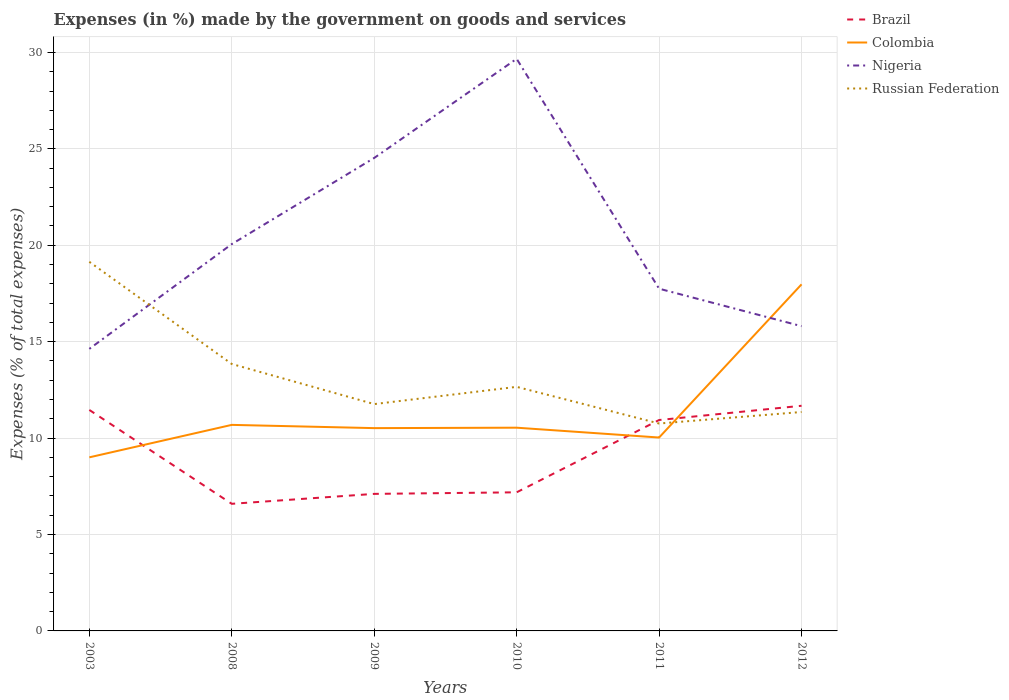How many different coloured lines are there?
Provide a short and direct response. 4. Across all years, what is the maximum percentage of expenses made by the government on goods and services in Brazil?
Ensure brevity in your answer.  6.59. What is the total percentage of expenses made by the government on goods and services in Colombia in the graph?
Your answer should be very brief. -1.51. What is the difference between the highest and the second highest percentage of expenses made by the government on goods and services in Brazil?
Provide a short and direct response. 5.08. Is the percentage of expenses made by the government on goods and services in Colombia strictly greater than the percentage of expenses made by the government on goods and services in Nigeria over the years?
Your answer should be compact. No. How many lines are there?
Offer a terse response. 4. How many years are there in the graph?
Offer a terse response. 6. Does the graph contain any zero values?
Make the answer very short. No. Does the graph contain grids?
Provide a succinct answer. Yes. Where does the legend appear in the graph?
Provide a short and direct response. Top right. How are the legend labels stacked?
Offer a terse response. Vertical. What is the title of the graph?
Your answer should be very brief. Expenses (in %) made by the government on goods and services. Does "Cyprus" appear as one of the legend labels in the graph?
Make the answer very short. No. What is the label or title of the X-axis?
Your answer should be compact. Years. What is the label or title of the Y-axis?
Offer a terse response. Expenses (% of total expenses). What is the Expenses (% of total expenses) in Brazil in 2003?
Ensure brevity in your answer.  11.46. What is the Expenses (% of total expenses) of Colombia in 2003?
Offer a very short reply. 9. What is the Expenses (% of total expenses) of Nigeria in 2003?
Provide a succinct answer. 14.63. What is the Expenses (% of total expenses) in Russian Federation in 2003?
Ensure brevity in your answer.  19.14. What is the Expenses (% of total expenses) of Brazil in 2008?
Offer a terse response. 6.59. What is the Expenses (% of total expenses) of Colombia in 2008?
Your answer should be compact. 10.69. What is the Expenses (% of total expenses) of Nigeria in 2008?
Make the answer very short. 20.06. What is the Expenses (% of total expenses) of Russian Federation in 2008?
Offer a very short reply. 13.84. What is the Expenses (% of total expenses) in Brazil in 2009?
Your response must be concise. 7.11. What is the Expenses (% of total expenses) of Colombia in 2009?
Provide a short and direct response. 10.52. What is the Expenses (% of total expenses) in Nigeria in 2009?
Keep it short and to the point. 24.53. What is the Expenses (% of total expenses) in Russian Federation in 2009?
Offer a very short reply. 11.76. What is the Expenses (% of total expenses) in Brazil in 2010?
Provide a succinct answer. 7.19. What is the Expenses (% of total expenses) of Colombia in 2010?
Keep it short and to the point. 10.54. What is the Expenses (% of total expenses) in Nigeria in 2010?
Your response must be concise. 29.67. What is the Expenses (% of total expenses) in Russian Federation in 2010?
Offer a very short reply. 12.66. What is the Expenses (% of total expenses) in Brazil in 2011?
Your response must be concise. 10.94. What is the Expenses (% of total expenses) in Colombia in 2011?
Provide a short and direct response. 10.03. What is the Expenses (% of total expenses) in Nigeria in 2011?
Ensure brevity in your answer.  17.75. What is the Expenses (% of total expenses) of Russian Federation in 2011?
Your response must be concise. 10.76. What is the Expenses (% of total expenses) of Brazil in 2012?
Offer a very short reply. 11.68. What is the Expenses (% of total expenses) of Colombia in 2012?
Provide a short and direct response. 17.97. What is the Expenses (% of total expenses) of Nigeria in 2012?
Provide a succinct answer. 15.8. What is the Expenses (% of total expenses) in Russian Federation in 2012?
Your response must be concise. 11.35. Across all years, what is the maximum Expenses (% of total expenses) in Brazil?
Offer a very short reply. 11.68. Across all years, what is the maximum Expenses (% of total expenses) of Colombia?
Offer a terse response. 17.97. Across all years, what is the maximum Expenses (% of total expenses) of Nigeria?
Your response must be concise. 29.67. Across all years, what is the maximum Expenses (% of total expenses) of Russian Federation?
Give a very brief answer. 19.14. Across all years, what is the minimum Expenses (% of total expenses) of Brazil?
Offer a terse response. 6.59. Across all years, what is the minimum Expenses (% of total expenses) in Colombia?
Your answer should be compact. 9. Across all years, what is the minimum Expenses (% of total expenses) in Nigeria?
Your response must be concise. 14.63. Across all years, what is the minimum Expenses (% of total expenses) in Russian Federation?
Give a very brief answer. 10.76. What is the total Expenses (% of total expenses) of Brazil in the graph?
Your answer should be very brief. 54.96. What is the total Expenses (% of total expenses) in Colombia in the graph?
Your response must be concise. 68.75. What is the total Expenses (% of total expenses) in Nigeria in the graph?
Offer a very short reply. 122.44. What is the total Expenses (% of total expenses) in Russian Federation in the graph?
Keep it short and to the point. 79.52. What is the difference between the Expenses (% of total expenses) of Brazil in 2003 and that in 2008?
Provide a short and direct response. 4.87. What is the difference between the Expenses (% of total expenses) of Colombia in 2003 and that in 2008?
Make the answer very short. -1.68. What is the difference between the Expenses (% of total expenses) of Nigeria in 2003 and that in 2008?
Offer a terse response. -5.43. What is the difference between the Expenses (% of total expenses) in Russian Federation in 2003 and that in 2008?
Ensure brevity in your answer.  5.3. What is the difference between the Expenses (% of total expenses) of Brazil in 2003 and that in 2009?
Your answer should be very brief. 4.35. What is the difference between the Expenses (% of total expenses) of Colombia in 2003 and that in 2009?
Offer a terse response. -1.51. What is the difference between the Expenses (% of total expenses) of Nigeria in 2003 and that in 2009?
Provide a short and direct response. -9.9. What is the difference between the Expenses (% of total expenses) in Russian Federation in 2003 and that in 2009?
Provide a short and direct response. 7.38. What is the difference between the Expenses (% of total expenses) in Brazil in 2003 and that in 2010?
Your response must be concise. 4.27. What is the difference between the Expenses (% of total expenses) in Colombia in 2003 and that in 2010?
Give a very brief answer. -1.54. What is the difference between the Expenses (% of total expenses) of Nigeria in 2003 and that in 2010?
Give a very brief answer. -15.04. What is the difference between the Expenses (% of total expenses) in Russian Federation in 2003 and that in 2010?
Ensure brevity in your answer.  6.48. What is the difference between the Expenses (% of total expenses) of Brazil in 2003 and that in 2011?
Offer a very short reply. 0.52. What is the difference between the Expenses (% of total expenses) in Colombia in 2003 and that in 2011?
Provide a short and direct response. -1.03. What is the difference between the Expenses (% of total expenses) of Nigeria in 2003 and that in 2011?
Your answer should be compact. -3.12. What is the difference between the Expenses (% of total expenses) in Russian Federation in 2003 and that in 2011?
Your answer should be very brief. 8.39. What is the difference between the Expenses (% of total expenses) in Brazil in 2003 and that in 2012?
Your answer should be compact. -0.22. What is the difference between the Expenses (% of total expenses) in Colombia in 2003 and that in 2012?
Give a very brief answer. -8.97. What is the difference between the Expenses (% of total expenses) of Nigeria in 2003 and that in 2012?
Make the answer very short. -1.18. What is the difference between the Expenses (% of total expenses) in Russian Federation in 2003 and that in 2012?
Make the answer very short. 7.79. What is the difference between the Expenses (% of total expenses) in Brazil in 2008 and that in 2009?
Your answer should be compact. -0.52. What is the difference between the Expenses (% of total expenses) of Colombia in 2008 and that in 2009?
Keep it short and to the point. 0.17. What is the difference between the Expenses (% of total expenses) of Nigeria in 2008 and that in 2009?
Your response must be concise. -4.47. What is the difference between the Expenses (% of total expenses) in Russian Federation in 2008 and that in 2009?
Offer a very short reply. 2.08. What is the difference between the Expenses (% of total expenses) in Brazil in 2008 and that in 2010?
Offer a very short reply. -0.6. What is the difference between the Expenses (% of total expenses) in Colombia in 2008 and that in 2010?
Offer a very short reply. 0.15. What is the difference between the Expenses (% of total expenses) in Nigeria in 2008 and that in 2010?
Keep it short and to the point. -9.61. What is the difference between the Expenses (% of total expenses) of Russian Federation in 2008 and that in 2010?
Your answer should be very brief. 1.19. What is the difference between the Expenses (% of total expenses) of Brazil in 2008 and that in 2011?
Make the answer very short. -4.35. What is the difference between the Expenses (% of total expenses) in Colombia in 2008 and that in 2011?
Offer a very short reply. 0.66. What is the difference between the Expenses (% of total expenses) of Nigeria in 2008 and that in 2011?
Provide a succinct answer. 2.31. What is the difference between the Expenses (% of total expenses) in Russian Federation in 2008 and that in 2011?
Ensure brevity in your answer.  3.09. What is the difference between the Expenses (% of total expenses) in Brazil in 2008 and that in 2012?
Ensure brevity in your answer.  -5.08. What is the difference between the Expenses (% of total expenses) in Colombia in 2008 and that in 2012?
Your response must be concise. -7.29. What is the difference between the Expenses (% of total expenses) in Nigeria in 2008 and that in 2012?
Offer a very short reply. 4.26. What is the difference between the Expenses (% of total expenses) of Russian Federation in 2008 and that in 2012?
Offer a terse response. 2.49. What is the difference between the Expenses (% of total expenses) in Brazil in 2009 and that in 2010?
Your answer should be very brief. -0.08. What is the difference between the Expenses (% of total expenses) of Colombia in 2009 and that in 2010?
Ensure brevity in your answer.  -0.02. What is the difference between the Expenses (% of total expenses) in Nigeria in 2009 and that in 2010?
Your response must be concise. -5.14. What is the difference between the Expenses (% of total expenses) in Russian Federation in 2009 and that in 2010?
Offer a terse response. -0.89. What is the difference between the Expenses (% of total expenses) in Brazil in 2009 and that in 2011?
Your response must be concise. -3.83. What is the difference between the Expenses (% of total expenses) of Colombia in 2009 and that in 2011?
Offer a very short reply. 0.49. What is the difference between the Expenses (% of total expenses) of Nigeria in 2009 and that in 2011?
Ensure brevity in your answer.  6.78. What is the difference between the Expenses (% of total expenses) in Russian Federation in 2009 and that in 2011?
Make the answer very short. 1.01. What is the difference between the Expenses (% of total expenses) in Brazil in 2009 and that in 2012?
Provide a short and direct response. -4.57. What is the difference between the Expenses (% of total expenses) in Colombia in 2009 and that in 2012?
Your answer should be very brief. -7.46. What is the difference between the Expenses (% of total expenses) in Nigeria in 2009 and that in 2012?
Give a very brief answer. 8.72. What is the difference between the Expenses (% of total expenses) of Russian Federation in 2009 and that in 2012?
Offer a terse response. 0.41. What is the difference between the Expenses (% of total expenses) of Brazil in 2010 and that in 2011?
Your answer should be very brief. -3.75. What is the difference between the Expenses (% of total expenses) of Colombia in 2010 and that in 2011?
Your answer should be very brief. 0.51. What is the difference between the Expenses (% of total expenses) in Nigeria in 2010 and that in 2011?
Make the answer very short. 11.92. What is the difference between the Expenses (% of total expenses) of Russian Federation in 2010 and that in 2011?
Ensure brevity in your answer.  1.9. What is the difference between the Expenses (% of total expenses) in Brazil in 2010 and that in 2012?
Your response must be concise. -4.49. What is the difference between the Expenses (% of total expenses) in Colombia in 2010 and that in 2012?
Ensure brevity in your answer.  -7.43. What is the difference between the Expenses (% of total expenses) in Nigeria in 2010 and that in 2012?
Your answer should be compact. 13.86. What is the difference between the Expenses (% of total expenses) in Russian Federation in 2010 and that in 2012?
Make the answer very short. 1.3. What is the difference between the Expenses (% of total expenses) in Brazil in 2011 and that in 2012?
Provide a succinct answer. -0.74. What is the difference between the Expenses (% of total expenses) of Colombia in 2011 and that in 2012?
Provide a succinct answer. -7.94. What is the difference between the Expenses (% of total expenses) of Nigeria in 2011 and that in 2012?
Your answer should be compact. 1.94. What is the difference between the Expenses (% of total expenses) of Russian Federation in 2011 and that in 2012?
Your response must be concise. -0.6. What is the difference between the Expenses (% of total expenses) of Brazil in 2003 and the Expenses (% of total expenses) of Colombia in 2008?
Your answer should be compact. 0.77. What is the difference between the Expenses (% of total expenses) of Brazil in 2003 and the Expenses (% of total expenses) of Nigeria in 2008?
Offer a very short reply. -8.6. What is the difference between the Expenses (% of total expenses) in Brazil in 2003 and the Expenses (% of total expenses) in Russian Federation in 2008?
Offer a terse response. -2.38. What is the difference between the Expenses (% of total expenses) in Colombia in 2003 and the Expenses (% of total expenses) in Nigeria in 2008?
Provide a succinct answer. -11.06. What is the difference between the Expenses (% of total expenses) of Colombia in 2003 and the Expenses (% of total expenses) of Russian Federation in 2008?
Keep it short and to the point. -4.84. What is the difference between the Expenses (% of total expenses) of Nigeria in 2003 and the Expenses (% of total expenses) of Russian Federation in 2008?
Offer a terse response. 0.78. What is the difference between the Expenses (% of total expenses) of Brazil in 2003 and the Expenses (% of total expenses) of Colombia in 2009?
Offer a very short reply. 0.94. What is the difference between the Expenses (% of total expenses) of Brazil in 2003 and the Expenses (% of total expenses) of Nigeria in 2009?
Your response must be concise. -13.07. What is the difference between the Expenses (% of total expenses) of Brazil in 2003 and the Expenses (% of total expenses) of Russian Federation in 2009?
Your answer should be very brief. -0.3. What is the difference between the Expenses (% of total expenses) in Colombia in 2003 and the Expenses (% of total expenses) in Nigeria in 2009?
Offer a very short reply. -15.53. What is the difference between the Expenses (% of total expenses) of Colombia in 2003 and the Expenses (% of total expenses) of Russian Federation in 2009?
Give a very brief answer. -2.76. What is the difference between the Expenses (% of total expenses) in Nigeria in 2003 and the Expenses (% of total expenses) in Russian Federation in 2009?
Make the answer very short. 2.86. What is the difference between the Expenses (% of total expenses) of Brazil in 2003 and the Expenses (% of total expenses) of Colombia in 2010?
Provide a succinct answer. 0.92. What is the difference between the Expenses (% of total expenses) of Brazil in 2003 and the Expenses (% of total expenses) of Nigeria in 2010?
Make the answer very short. -18.21. What is the difference between the Expenses (% of total expenses) of Brazil in 2003 and the Expenses (% of total expenses) of Russian Federation in 2010?
Keep it short and to the point. -1.2. What is the difference between the Expenses (% of total expenses) of Colombia in 2003 and the Expenses (% of total expenses) of Nigeria in 2010?
Provide a succinct answer. -20.67. What is the difference between the Expenses (% of total expenses) of Colombia in 2003 and the Expenses (% of total expenses) of Russian Federation in 2010?
Keep it short and to the point. -3.66. What is the difference between the Expenses (% of total expenses) in Nigeria in 2003 and the Expenses (% of total expenses) in Russian Federation in 2010?
Provide a succinct answer. 1.97. What is the difference between the Expenses (% of total expenses) in Brazil in 2003 and the Expenses (% of total expenses) in Colombia in 2011?
Your answer should be compact. 1.43. What is the difference between the Expenses (% of total expenses) of Brazil in 2003 and the Expenses (% of total expenses) of Nigeria in 2011?
Offer a terse response. -6.29. What is the difference between the Expenses (% of total expenses) in Brazil in 2003 and the Expenses (% of total expenses) in Russian Federation in 2011?
Offer a terse response. 0.7. What is the difference between the Expenses (% of total expenses) of Colombia in 2003 and the Expenses (% of total expenses) of Nigeria in 2011?
Ensure brevity in your answer.  -8.75. What is the difference between the Expenses (% of total expenses) of Colombia in 2003 and the Expenses (% of total expenses) of Russian Federation in 2011?
Make the answer very short. -1.75. What is the difference between the Expenses (% of total expenses) in Nigeria in 2003 and the Expenses (% of total expenses) in Russian Federation in 2011?
Provide a succinct answer. 3.87. What is the difference between the Expenses (% of total expenses) in Brazil in 2003 and the Expenses (% of total expenses) in Colombia in 2012?
Offer a terse response. -6.51. What is the difference between the Expenses (% of total expenses) of Brazil in 2003 and the Expenses (% of total expenses) of Nigeria in 2012?
Offer a terse response. -4.34. What is the difference between the Expenses (% of total expenses) in Brazil in 2003 and the Expenses (% of total expenses) in Russian Federation in 2012?
Give a very brief answer. 0.11. What is the difference between the Expenses (% of total expenses) of Colombia in 2003 and the Expenses (% of total expenses) of Nigeria in 2012?
Your response must be concise. -6.8. What is the difference between the Expenses (% of total expenses) in Colombia in 2003 and the Expenses (% of total expenses) in Russian Federation in 2012?
Provide a succinct answer. -2.35. What is the difference between the Expenses (% of total expenses) in Nigeria in 2003 and the Expenses (% of total expenses) in Russian Federation in 2012?
Give a very brief answer. 3.27. What is the difference between the Expenses (% of total expenses) in Brazil in 2008 and the Expenses (% of total expenses) in Colombia in 2009?
Offer a terse response. -3.92. What is the difference between the Expenses (% of total expenses) of Brazil in 2008 and the Expenses (% of total expenses) of Nigeria in 2009?
Provide a succinct answer. -17.94. What is the difference between the Expenses (% of total expenses) of Brazil in 2008 and the Expenses (% of total expenses) of Russian Federation in 2009?
Offer a terse response. -5.17. What is the difference between the Expenses (% of total expenses) of Colombia in 2008 and the Expenses (% of total expenses) of Nigeria in 2009?
Ensure brevity in your answer.  -13.84. What is the difference between the Expenses (% of total expenses) of Colombia in 2008 and the Expenses (% of total expenses) of Russian Federation in 2009?
Offer a terse response. -1.08. What is the difference between the Expenses (% of total expenses) in Nigeria in 2008 and the Expenses (% of total expenses) in Russian Federation in 2009?
Ensure brevity in your answer.  8.3. What is the difference between the Expenses (% of total expenses) in Brazil in 2008 and the Expenses (% of total expenses) in Colombia in 2010?
Keep it short and to the point. -3.95. What is the difference between the Expenses (% of total expenses) in Brazil in 2008 and the Expenses (% of total expenses) in Nigeria in 2010?
Offer a terse response. -23.08. What is the difference between the Expenses (% of total expenses) in Brazil in 2008 and the Expenses (% of total expenses) in Russian Federation in 2010?
Give a very brief answer. -6.07. What is the difference between the Expenses (% of total expenses) in Colombia in 2008 and the Expenses (% of total expenses) in Nigeria in 2010?
Your answer should be very brief. -18.98. What is the difference between the Expenses (% of total expenses) in Colombia in 2008 and the Expenses (% of total expenses) in Russian Federation in 2010?
Ensure brevity in your answer.  -1.97. What is the difference between the Expenses (% of total expenses) in Nigeria in 2008 and the Expenses (% of total expenses) in Russian Federation in 2010?
Provide a short and direct response. 7.4. What is the difference between the Expenses (% of total expenses) of Brazil in 2008 and the Expenses (% of total expenses) of Colombia in 2011?
Keep it short and to the point. -3.44. What is the difference between the Expenses (% of total expenses) in Brazil in 2008 and the Expenses (% of total expenses) in Nigeria in 2011?
Offer a terse response. -11.16. What is the difference between the Expenses (% of total expenses) of Brazil in 2008 and the Expenses (% of total expenses) of Russian Federation in 2011?
Your answer should be compact. -4.16. What is the difference between the Expenses (% of total expenses) in Colombia in 2008 and the Expenses (% of total expenses) in Nigeria in 2011?
Offer a terse response. -7.06. What is the difference between the Expenses (% of total expenses) in Colombia in 2008 and the Expenses (% of total expenses) in Russian Federation in 2011?
Offer a very short reply. -0.07. What is the difference between the Expenses (% of total expenses) in Nigeria in 2008 and the Expenses (% of total expenses) in Russian Federation in 2011?
Your answer should be very brief. 9.3. What is the difference between the Expenses (% of total expenses) in Brazil in 2008 and the Expenses (% of total expenses) in Colombia in 2012?
Make the answer very short. -11.38. What is the difference between the Expenses (% of total expenses) in Brazil in 2008 and the Expenses (% of total expenses) in Nigeria in 2012?
Your answer should be compact. -9.21. What is the difference between the Expenses (% of total expenses) in Brazil in 2008 and the Expenses (% of total expenses) in Russian Federation in 2012?
Keep it short and to the point. -4.76. What is the difference between the Expenses (% of total expenses) in Colombia in 2008 and the Expenses (% of total expenses) in Nigeria in 2012?
Ensure brevity in your answer.  -5.12. What is the difference between the Expenses (% of total expenses) in Colombia in 2008 and the Expenses (% of total expenses) in Russian Federation in 2012?
Offer a terse response. -0.67. What is the difference between the Expenses (% of total expenses) of Nigeria in 2008 and the Expenses (% of total expenses) of Russian Federation in 2012?
Provide a succinct answer. 8.71. What is the difference between the Expenses (% of total expenses) of Brazil in 2009 and the Expenses (% of total expenses) of Colombia in 2010?
Keep it short and to the point. -3.43. What is the difference between the Expenses (% of total expenses) in Brazil in 2009 and the Expenses (% of total expenses) in Nigeria in 2010?
Ensure brevity in your answer.  -22.56. What is the difference between the Expenses (% of total expenses) of Brazil in 2009 and the Expenses (% of total expenses) of Russian Federation in 2010?
Your response must be concise. -5.55. What is the difference between the Expenses (% of total expenses) of Colombia in 2009 and the Expenses (% of total expenses) of Nigeria in 2010?
Ensure brevity in your answer.  -19.15. What is the difference between the Expenses (% of total expenses) in Colombia in 2009 and the Expenses (% of total expenses) in Russian Federation in 2010?
Keep it short and to the point. -2.14. What is the difference between the Expenses (% of total expenses) of Nigeria in 2009 and the Expenses (% of total expenses) of Russian Federation in 2010?
Your answer should be very brief. 11.87. What is the difference between the Expenses (% of total expenses) of Brazil in 2009 and the Expenses (% of total expenses) of Colombia in 2011?
Make the answer very short. -2.92. What is the difference between the Expenses (% of total expenses) of Brazil in 2009 and the Expenses (% of total expenses) of Nigeria in 2011?
Offer a very short reply. -10.64. What is the difference between the Expenses (% of total expenses) in Brazil in 2009 and the Expenses (% of total expenses) in Russian Federation in 2011?
Your answer should be compact. -3.65. What is the difference between the Expenses (% of total expenses) of Colombia in 2009 and the Expenses (% of total expenses) of Nigeria in 2011?
Make the answer very short. -7.23. What is the difference between the Expenses (% of total expenses) of Colombia in 2009 and the Expenses (% of total expenses) of Russian Federation in 2011?
Your answer should be compact. -0.24. What is the difference between the Expenses (% of total expenses) in Nigeria in 2009 and the Expenses (% of total expenses) in Russian Federation in 2011?
Ensure brevity in your answer.  13.77. What is the difference between the Expenses (% of total expenses) of Brazil in 2009 and the Expenses (% of total expenses) of Colombia in 2012?
Ensure brevity in your answer.  -10.87. What is the difference between the Expenses (% of total expenses) in Brazil in 2009 and the Expenses (% of total expenses) in Nigeria in 2012?
Your answer should be very brief. -8.7. What is the difference between the Expenses (% of total expenses) of Brazil in 2009 and the Expenses (% of total expenses) of Russian Federation in 2012?
Offer a very short reply. -4.25. What is the difference between the Expenses (% of total expenses) in Colombia in 2009 and the Expenses (% of total expenses) in Nigeria in 2012?
Your response must be concise. -5.29. What is the difference between the Expenses (% of total expenses) in Colombia in 2009 and the Expenses (% of total expenses) in Russian Federation in 2012?
Your answer should be very brief. -0.84. What is the difference between the Expenses (% of total expenses) in Nigeria in 2009 and the Expenses (% of total expenses) in Russian Federation in 2012?
Your answer should be compact. 13.18. What is the difference between the Expenses (% of total expenses) of Brazil in 2010 and the Expenses (% of total expenses) of Colombia in 2011?
Give a very brief answer. -2.84. What is the difference between the Expenses (% of total expenses) in Brazil in 2010 and the Expenses (% of total expenses) in Nigeria in 2011?
Offer a terse response. -10.56. What is the difference between the Expenses (% of total expenses) in Brazil in 2010 and the Expenses (% of total expenses) in Russian Federation in 2011?
Provide a short and direct response. -3.57. What is the difference between the Expenses (% of total expenses) of Colombia in 2010 and the Expenses (% of total expenses) of Nigeria in 2011?
Offer a very short reply. -7.21. What is the difference between the Expenses (% of total expenses) of Colombia in 2010 and the Expenses (% of total expenses) of Russian Federation in 2011?
Make the answer very short. -0.22. What is the difference between the Expenses (% of total expenses) of Nigeria in 2010 and the Expenses (% of total expenses) of Russian Federation in 2011?
Your response must be concise. 18.91. What is the difference between the Expenses (% of total expenses) of Brazil in 2010 and the Expenses (% of total expenses) of Colombia in 2012?
Your answer should be very brief. -10.79. What is the difference between the Expenses (% of total expenses) in Brazil in 2010 and the Expenses (% of total expenses) in Nigeria in 2012?
Your answer should be compact. -8.62. What is the difference between the Expenses (% of total expenses) of Brazil in 2010 and the Expenses (% of total expenses) of Russian Federation in 2012?
Your response must be concise. -4.17. What is the difference between the Expenses (% of total expenses) of Colombia in 2010 and the Expenses (% of total expenses) of Nigeria in 2012?
Your answer should be very brief. -5.27. What is the difference between the Expenses (% of total expenses) of Colombia in 2010 and the Expenses (% of total expenses) of Russian Federation in 2012?
Your response must be concise. -0.81. What is the difference between the Expenses (% of total expenses) in Nigeria in 2010 and the Expenses (% of total expenses) in Russian Federation in 2012?
Offer a terse response. 18.32. What is the difference between the Expenses (% of total expenses) in Brazil in 2011 and the Expenses (% of total expenses) in Colombia in 2012?
Offer a terse response. -7.04. What is the difference between the Expenses (% of total expenses) in Brazil in 2011 and the Expenses (% of total expenses) in Nigeria in 2012?
Offer a terse response. -4.87. What is the difference between the Expenses (% of total expenses) in Brazil in 2011 and the Expenses (% of total expenses) in Russian Federation in 2012?
Your answer should be compact. -0.42. What is the difference between the Expenses (% of total expenses) in Colombia in 2011 and the Expenses (% of total expenses) in Nigeria in 2012?
Provide a short and direct response. -5.78. What is the difference between the Expenses (% of total expenses) in Colombia in 2011 and the Expenses (% of total expenses) in Russian Federation in 2012?
Your response must be concise. -1.32. What is the difference between the Expenses (% of total expenses) of Nigeria in 2011 and the Expenses (% of total expenses) of Russian Federation in 2012?
Offer a very short reply. 6.39. What is the average Expenses (% of total expenses) in Brazil per year?
Keep it short and to the point. 9.16. What is the average Expenses (% of total expenses) of Colombia per year?
Make the answer very short. 11.46. What is the average Expenses (% of total expenses) of Nigeria per year?
Your answer should be very brief. 20.41. What is the average Expenses (% of total expenses) of Russian Federation per year?
Your answer should be very brief. 13.25. In the year 2003, what is the difference between the Expenses (% of total expenses) in Brazil and Expenses (% of total expenses) in Colombia?
Ensure brevity in your answer.  2.46. In the year 2003, what is the difference between the Expenses (% of total expenses) in Brazil and Expenses (% of total expenses) in Nigeria?
Your answer should be very brief. -3.17. In the year 2003, what is the difference between the Expenses (% of total expenses) in Brazil and Expenses (% of total expenses) in Russian Federation?
Provide a succinct answer. -7.68. In the year 2003, what is the difference between the Expenses (% of total expenses) in Colombia and Expenses (% of total expenses) in Nigeria?
Offer a very short reply. -5.62. In the year 2003, what is the difference between the Expenses (% of total expenses) in Colombia and Expenses (% of total expenses) in Russian Federation?
Provide a short and direct response. -10.14. In the year 2003, what is the difference between the Expenses (% of total expenses) of Nigeria and Expenses (% of total expenses) of Russian Federation?
Your answer should be very brief. -4.52. In the year 2008, what is the difference between the Expenses (% of total expenses) of Brazil and Expenses (% of total expenses) of Colombia?
Make the answer very short. -4.09. In the year 2008, what is the difference between the Expenses (% of total expenses) in Brazil and Expenses (% of total expenses) in Nigeria?
Provide a short and direct response. -13.47. In the year 2008, what is the difference between the Expenses (% of total expenses) in Brazil and Expenses (% of total expenses) in Russian Federation?
Ensure brevity in your answer.  -7.25. In the year 2008, what is the difference between the Expenses (% of total expenses) in Colombia and Expenses (% of total expenses) in Nigeria?
Your answer should be compact. -9.38. In the year 2008, what is the difference between the Expenses (% of total expenses) of Colombia and Expenses (% of total expenses) of Russian Federation?
Provide a succinct answer. -3.16. In the year 2008, what is the difference between the Expenses (% of total expenses) in Nigeria and Expenses (% of total expenses) in Russian Federation?
Offer a very short reply. 6.22. In the year 2009, what is the difference between the Expenses (% of total expenses) of Brazil and Expenses (% of total expenses) of Colombia?
Ensure brevity in your answer.  -3.41. In the year 2009, what is the difference between the Expenses (% of total expenses) of Brazil and Expenses (% of total expenses) of Nigeria?
Provide a succinct answer. -17.42. In the year 2009, what is the difference between the Expenses (% of total expenses) in Brazil and Expenses (% of total expenses) in Russian Federation?
Your answer should be very brief. -4.66. In the year 2009, what is the difference between the Expenses (% of total expenses) of Colombia and Expenses (% of total expenses) of Nigeria?
Make the answer very short. -14.01. In the year 2009, what is the difference between the Expenses (% of total expenses) of Colombia and Expenses (% of total expenses) of Russian Federation?
Ensure brevity in your answer.  -1.25. In the year 2009, what is the difference between the Expenses (% of total expenses) in Nigeria and Expenses (% of total expenses) in Russian Federation?
Offer a very short reply. 12.77. In the year 2010, what is the difference between the Expenses (% of total expenses) of Brazil and Expenses (% of total expenses) of Colombia?
Ensure brevity in your answer.  -3.35. In the year 2010, what is the difference between the Expenses (% of total expenses) in Brazil and Expenses (% of total expenses) in Nigeria?
Your answer should be compact. -22.48. In the year 2010, what is the difference between the Expenses (% of total expenses) of Brazil and Expenses (% of total expenses) of Russian Federation?
Your answer should be very brief. -5.47. In the year 2010, what is the difference between the Expenses (% of total expenses) in Colombia and Expenses (% of total expenses) in Nigeria?
Give a very brief answer. -19.13. In the year 2010, what is the difference between the Expenses (% of total expenses) in Colombia and Expenses (% of total expenses) in Russian Federation?
Provide a succinct answer. -2.12. In the year 2010, what is the difference between the Expenses (% of total expenses) of Nigeria and Expenses (% of total expenses) of Russian Federation?
Make the answer very short. 17.01. In the year 2011, what is the difference between the Expenses (% of total expenses) of Brazil and Expenses (% of total expenses) of Colombia?
Your answer should be compact. 0.91. In the year 2011, what is the difference between the Expenses (% of total expenses) in Brazil and Expenses (% of total expenses) in Nigeria?
Your response must be concise. -6.81. In the year 2011, what is the difference between the Expenses (% of total expenses) in Brazil and Expenses (% of total expenses) in Russian Federation?
Your answer should be very brief. 0.18. In the year 2011, what is the difference between the Expenses (% of total expenses) in Colombia and Expenses (% of total expenses) in Nigeria?
Offer a very short reply. -7.72. In the year 2011, what is the difference between the Expenses (% of total expenses) of Colombia and Expenses (% of total expenses) of Russian Federation?
Offer a very short reply. -0.73. In the year 2011, what is the difference between the Expenses (% of total expenses) in Nigeria and Expenses (% of total expenses) in Russian Federation?
Provide a short and direct response. 6.99. In the year 2012, what is the difference between the Expenses (% of total expenses) of Brazil and Expenses (% of total expenses) of Colombia?
Keep it short and to the point. -6.3. In the year 2012, what is the difference between the Expenses (% of total expenses) of Brazil and Expenses (% of total expenses) of Nigeria?
Your answer should be compact. -4.13. In the year 2012, what is the difference between the Expenses (% of total expenses) of Brazil and Expenses (% of total expenses) of Russian Federation?
Provide a short and direct response. 0.32. In the year 2012, what is the difference between the Expenses (% of total expenses) of Colombia and Expenses (% of total expenses) of Nigeria?
Provide a short and direct response. 2.17. In the year 2012, what is the difference between the Expenses (% of total expenses) of Colombia and Expenses (% of total expenses) of Russian Federation?
Offer a terse response. 6.62. In the year 2012, what is the difference between the Expenses (% of total expenses) in Nigeria and Expenses (% of total expenses) in Russian Federation?
Ensure brevity in your answer.  4.45. What is the ratio of the Expenses (% of total expenses) in Brazil in 2003 to that in 2008?
Your answer should be very brief. 1.74. What is the ratio of the Expenses (% of total expenses) of Colombia in 2003 to that in 2008?
Offer a terse response. 0.84. What is the ratio of the Expenses (% of total expenses) of Nigeria in 2003 to that in 2008?
Offer a very short reply. 0.73. What is the ratio of the Expenses (% of total expenses) of Russian Federation in 2003 to that in 2008?
Offer a very short reply. 1.38. What is the ratio of the Expenses (% of total expenses) in Brazil in 2003 to that in 2009?
Give a very brief answer. 1.61. What is the ratio of the Expenses (% of total expenses) of Colombia in 2003 to that in 2009?
Your response must be concise. 0.86. What is the ratio of the Expenses (% of total expenses) in Nigeria in 2003 to that in 2009?
Your response must be concise. 0.6. What is the ratio of the Expenses (% of total expenses) of Russian Federation in 2003 to that in 2009?
Your response must be concise. 1.63. What is the ratio of the Expenses (% of total expenses) in Brazil in 2003 to that in 2010?
Your response must be concise. 1.59. What is the ratio of the Expenses (% of total expenses) of Colombia in 2003 to that in 2010?
Your response must be concise. 0.85. What is the ratio of the Expenses (% of total expenses) of Nigeria in 2003 to that in 2010?
Provide a short and direct response. 0.49. What is the ratio of the Expenses (% of total expenses) of Russian Federation in 2003 to that in 2010?
Your response must be concise. 1.51. What is the ratio of the Expenses (% of total expenses) of Brazil in 2003 to that in 2011?
Offer a very short reply. 1.05. What is the ratio of the Expenses (% of total expenses) in Colombia in 2003 to that in 2011?
Offer a very short reply. 0.9. What is the ratio of the Expenses (% of total expenses) in Nigeria in 2003 to that in 2011?
Your answer should be compact. 0.82. What is the ratio of the Expenses (% of total expenses) in Russian Federation in 2003 to that in 2011?
Keep it short and to the point. 1.78. What is the ratio of the Expenses (% of total expenses) in Brazil in 2003 to that in 2012?
Your response must be concise. 0.98. What is the ratio of the Expenses (% of total expenses) in Colombia in 2003 to that in 2012?
Keep it short and to the point. 0.5. What is the ratio of the Expenses (% of total expenses) of Nigeria in 2003 to that in 2012?
Your response must be concise. 0.93. What is the ratio of the Expenses (% of total expenses) of Russian Federation in 2003 to that in 2012?
Your answer should be very brief. 1.69. What is the ratio of the Expenses (% of total expenses) in Brazil in 2008 to that in 2009?
Offer a very short reply. 0.93. What is the ratio of the Expenses (% of total expenses) of Colombia in 2008 to that in 2009?
Make the answer very short. 1.02. What is the ratio of the Expenses (% of total expenses) of Nigeria in 2008 to that in 2009?
Your answer should be compact. 0.82. What is the ratio of the Expenses (% of total expenses) in Russian Federation in 2008 to that in 2009?
Make the answer very short. 1.18. What is the ratio of the Expenses (% of total expenses) in Brazil in 2008 to that in 2010?
Your answer should be compact. 0.92. What is the ratio of the Expenses (% of total expenses) in Colombia in 2008 to that in 2010?
Offer a terse response. 1.01. What is the ratio of the Expenses (% of total expenses) in Nigeria in 2008 to that in 2010?
Your answer should be compact. 0.68. What is the ratio of the Expenses (% of total expenses) in Russian Federation in 2008 to that in 2010?
Give a very brief answer. 1.09. What is the ratio of the Expenses (% of total expenses) in Brazil in 2008 to that in 2011?
Make the answer very short. 0.6. What is the ratio of the Expenses (% of total expenses) of Colombia in 2008 to that in 2011?
Provide a short and direct response. 1.07. What is the ratio of the Expenses (% of total expenses) of Nigeria in 2008 to that in 2011?
Provide a succinct answer. 1.13. What is the ratio of the Expenses (% of total expenses) in Russian Federation in 2008 to that in 2011?
Offer a terse response. 1.29. What is the ratio of the Expenses (% of total expenses) in Brazil in 2008 to that in 2012?
Your response must be concise. 0.56. What is the ratio of the Expenses (% of total expenses) in Colombia in 2008 to that in 2012?
Provide a succinct answer. 0.59. What is the ratio of the Expenses (% of total expenses) in Nigeria in 2008 to that in 2012?
Your response must be concise. 1.27. What is the ratio of the Expenses (% of total expenses) in Russian Federation in 2008 to that in 2012?
Give a very brief answer. 1.22. What is the ratio of the Expenses (% of total expenses) of Brazil in 2009 to that in 2010?
Offer a terse response. 0.99. What is the ratio of the Expenses (% of total expenses) of Colombia in 2009 to that in 2010?
Your response must be concise. 1. What is the ratio of the Expenses (% of total expenses) of Nigeria in 2009 to that in 2010?
Your answer should be compact. 0.83. What is the ratio of the Expenses (% of total expenses) in Russian Federation in 2009 to that in 2010?
Your answer should be compact. 0.93. What is the ratio of the Expenses (% of total expenses) of Brazil in 2009 to that in 2011?
Make the answer very short. 0.65. What is the ratio of the Expenses (% of total expenses) of Colombia in 2009 to that in 2011?
Keep it short and to the point. 1.05. What is the ratio of the Expenses (% of total expenses) of Nigeria in 2009 to that in 2011?
Your answer should be very brief. 1.38. What is the ratio of the Expenses (% of total expenses) of Russian Federation in 2009 to that in 2011?
Your answer should be very brief. 1.09. What is the ratio of the Expenses (% of total expenses) in Brazil in 2009 to that in 2012?
Your answer should be very brief. 0.61. What is the ratio of the Expenses (% of total expenses) of Colombia in 2009 to that in 2012?
Offer a terse response. 0.59. What is the ratio of the Expenses (% of total expenses) of Nigeria in 2009 to that in 2012?
Your response must be concise. 1.55. What is the ratio of the Expenses (% of total expenses) in Russian Federation in 2009 to that in 2012?
Give a very brief answer. 1.04. What is the ratio of the Expenses (% of total expenses) of Brazil in 2010 to that in 2011?
Offer a very short reply. 0.66. What is the ratio of the Expenses (% of total expenses) of Colombia in 2010 to that in 2011?
Offer a terse response. 1.05. What is the ratio of the Expenses (% of total expenses) in Nigeria in 2010 to that in 2011?
Your answer should be very brief. 1.67. What is the ratio of the Expenses (% of total expenses) of Russian Federation in 2010 to that in 2011?
Offer a very short reply. 1.18. What is the ratio of the Expenses (% of total expenses) of Brazil in 2010 to that in 2012?
Ensure brevity in your answer.  0.62. What is the ratio of the Expenses (% of total expenses) of Colombia in 2010 to that in 2012?
Give a very brief answer. 0.59. What is the ratio of the Expenses (% of total expenses) in Nigeria in 2010 to that in 2012?
Your response must be concise. 1.88. What is the ratio of the Expenses (% of total expenses) of Russian Federation in 2010 to that in 2012?
Your response must be concise. 1.11. What is the ratio of the Expenses (% of total expenses) of Brazil in 2011 to that in 2012?
Offer a very short reply. 0.94. What is the ratio of the Expenses (% of total expenses) in Colombia in 2011 to that in 2012?
Provide a short and direct response. 0.56. What is the ratio of the Expenses (% of total expenses) in Nigeria in 2011 to that in 2012?
Your response must be concise. 1.12. What is the difference between the highest and the second highest Expenses (% of total expenses) of Brazil?
Offer a very short reply. 0.22. What is the difference between the highest and the second highest Expenses (% of total expenses) in Colombia?
Make the answer very short. 7.29. What is the difference between the highest and the second highest Expenses (% of total expenses) in Nigeria?
Provide a short and direct response. 5.14. What is the difference between the highest and the second highest Expenses (% of total expenses) in Russian Federation?
Your answer should be very brief. 5.3. What is the difference between the highest and the lowest Expenses (% of total expenses) in Brazil?
Provide a succinct answer. 5.08. What is the difference between the highest and the lowest Expenses (% of total expenses) of Colombia?
Your answer should be compact. 8.97. What is the difference between the highest and the lowest Expenses (% of total expenses) in Nigeria?
Your response must be concise. 15.04. What is the difference between the highest and the lowest Expenses (% of total expenses) of Russian Federation?
Ensure brevity in your answer.  8.39. 